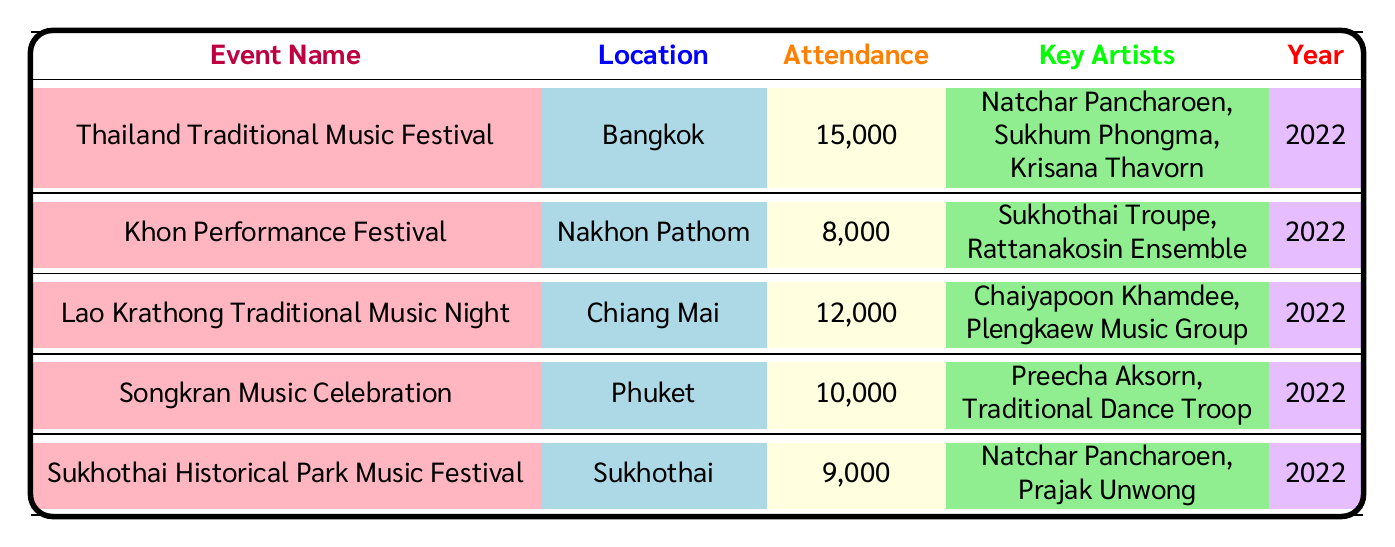What is the highest attendance figure from the events listed? The table shows attendance figures for several events. By examining the "Attendance" column, the highest value is 15000 for the "Thailand Traditional Music Festival" in 2022.
Answer: 15000 Which event took place in Chiang Mai? Referring to the "Location" column, the event listed in Chiang Mai is the "Lao Krathong Traditional Music Night," which has an attendance of 12000.
Answer: Lao Krathong Traditional Music Night How many events have Natchar Pancharoen as a key artist? Looking at the "Key Artists" column, Natchar Pancharoen appears in the "Thailand Traditional Music Festival" and the "Sukhothai Historical Park Music Festival." Therefore, there are two events featuring him as a key artist.
Answer: 2 What is the total attendance for all events in 2022? To find the total attendance, we sum the attendance figures: 15000 + 8000 + 12000 + 10000 + 9000 = 62000. This gives us the overall attendance for the year 2022.
Answer: 62000 Was the "Khon Performance Festival" held in Bangkok? By checking the "Location" column, the "Khon Performance Festival" is listed as taking place in Nakhon Pathom, not Bangkok.
Answer: No What is the median attendance for the events listed? First, we list the attendance figures in ascending order: 8000, 9000, 10000, 12000, 15000. Since there are five figures, the median is the middle value, which is the third figure: 10000.
Answer: 10000 In which year did the "Songkran Music Celebration" occur? The "Year" column directly shows that the "Songkran Music Celebration" took place in 2022, as indicated in the table.
Answer: 2022 How many events had attendance figures greater than 10000? Reviewing the attendance figures, the events with over 10000 attendees are the "Thailand Traditional Music Festival" (15000) and "Lao Krathong Traditional Music Night" (12000), making it a total of two events.
Answer: 2 Which event had the lowest attendance? The attendance figures are compared: 8000 (Khon Performance Festival) is the lowest attendance figure in the table.
Answer: Khon Performance Festival 